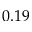<formula> <loc_0><loc_0><loc_500><loc_500>0 . 1 9</formula> 